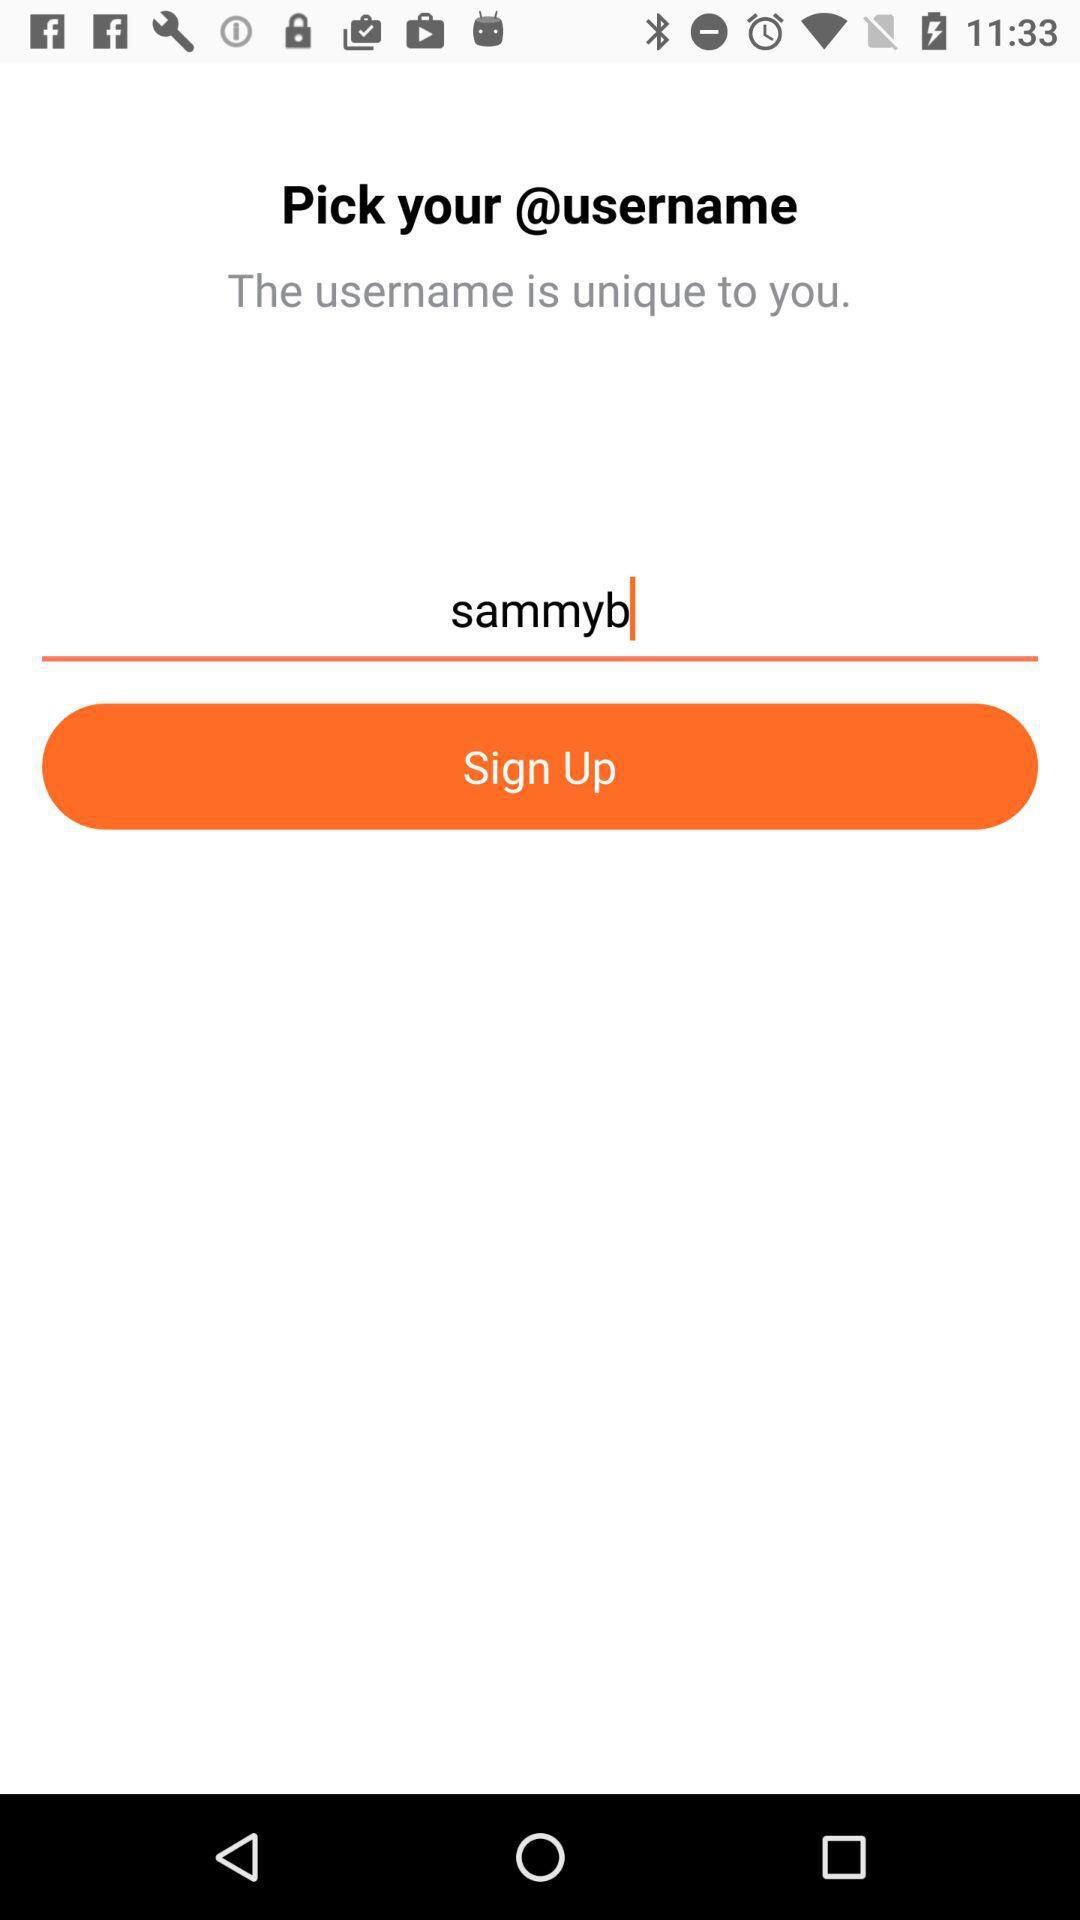What is the user name? The user name is "sammyb". 